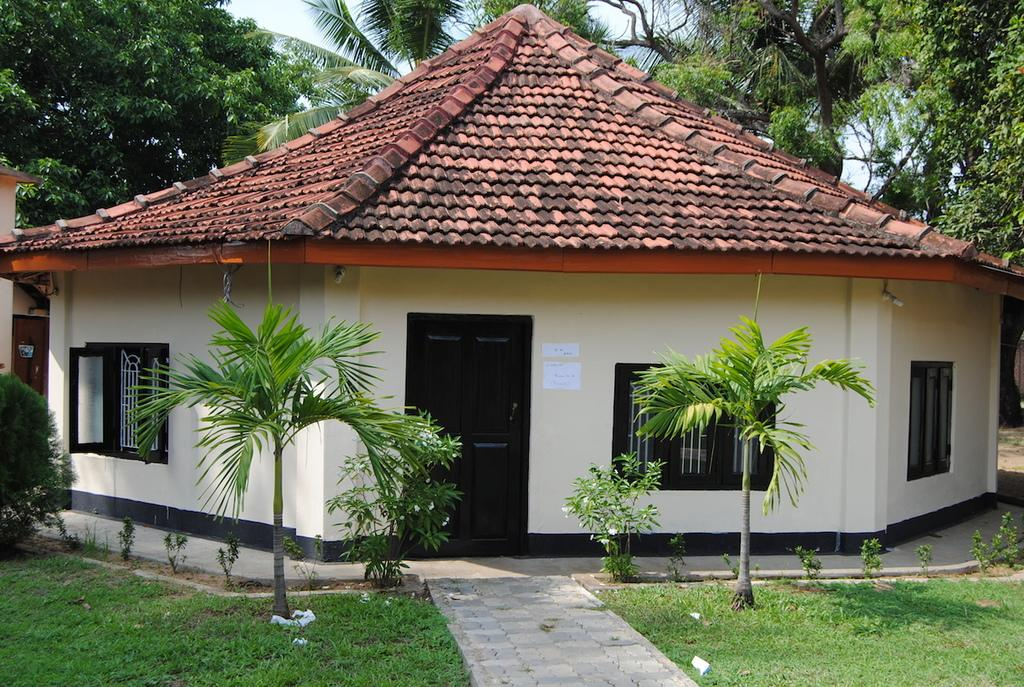What is the main structure in the center of the image? There is a shed in the center of the image. What type of vegetation can be seen in the image? There are trees visible in the image. What is the ground surface made of in the image? There is grass at the bottom of the image. What pathway is visible in the image? There is a walkway visible in the image. What can be seen in the background of the image? The sky is visible in the background of the image. What type of quartz can be seen in the image? There is no quartz present in the image. How many cars are driving on the walkway in the image? There are no cars or driving activity visible in the image; it features a shed, trees, grass, a walkway, and the sky. 